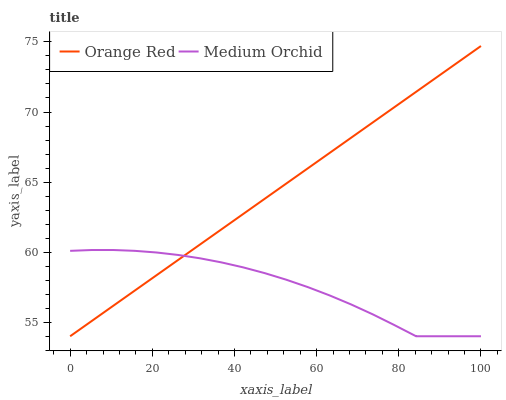Does Medium Orchid have the minimum area under the curve?
Answer yes or no. Yes. Does Orange Red have the maximum area under the curve?
Answer yes or no. Yes. Does Orange Red have the minimum area under the curve?
Answer yes or no. No. Is Orange Red the smoothest?
Answer yes or no. Yes. Is Medium Orchid the roughest?
Answer yes or no. Yes. Is Orange Red the roughest?
Answer yes or no. No. Does Medium Orchid have the lowest value?
Answer yes or no. Yes. Does Orange Red have the highest value?
Answer yes or no. Yes. Does Medium Orchid intersect Orange Red?
Answer yes or no. Yes. Is Medium Orchid less than Orange Red?
Answer yes or no. No. Is Medium Orchid greater than Orange Red?
Answer yes or no. No. 